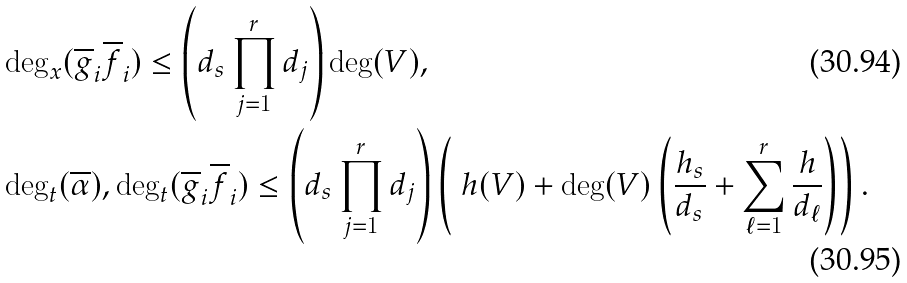<formula> <loc_0><loc_0><loc_500><loc_500>& \deg _ { x } ( \overline { g } _ { i } \overline { f } _ { i } ) \leq \left ( d _ { s } \prod _ { j = 1 } ^ { r } d _ { j } \right ) \deg ( V ) , \\ & \deg _ { t } ( \overline { \alpha } ) , \deg _ { t } ( \overline { g } _ { i } \overline { f } _ { i } ) \leq \left ( d _ { s } \prod _ { j = 1 } ^ { r } d _ { j } \right ) \left ( \ h ( V ) + \deg ( V ) \left ( \frac { h _ { s } } { d _ { s } } + \sum _ { \ell = 1 } ^ { r } \frac { h } { d _ { \ell } } \right ) \right ) .</formula> 